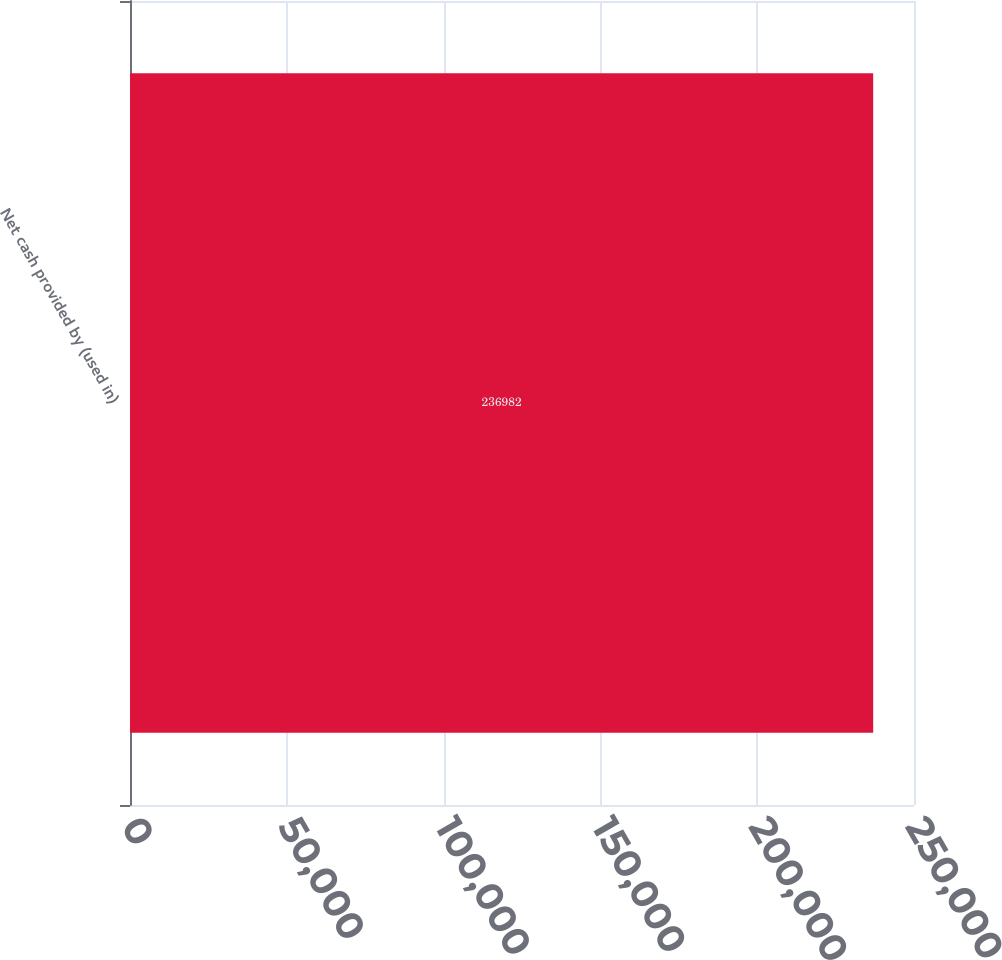Convert chart to OTSL. <chart><loc_0><loc_0><loc_500><loc_500><bar_chart><fcel>Net cash provided by (used in)<nl><fcel>236982<nl></chart> 